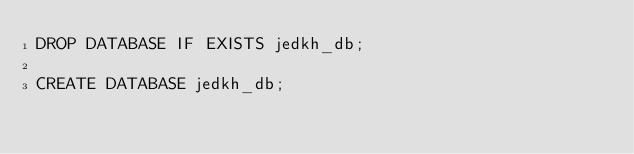<code> <loc_0><loc_0><loc_500><loc_500><_SQL_>DROP DATABASE IF EXISTS jedkh_db;

CREATE DATABASE jedkh_db;</code> 